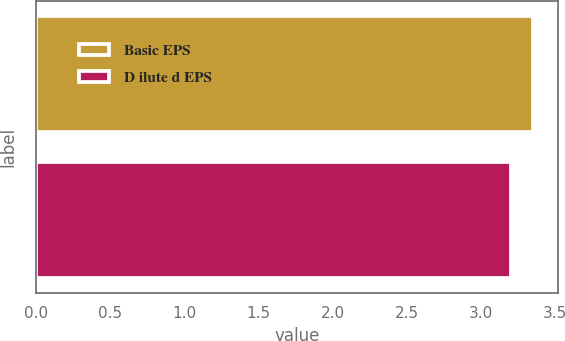<chart> <loc_0><loc_0><loc_500><loc_500><bar_chart><fcel>Basic EPS<fcel>D ilute d EPS<nl><fcel>3.35<fcel>3.2<nl></chart> 